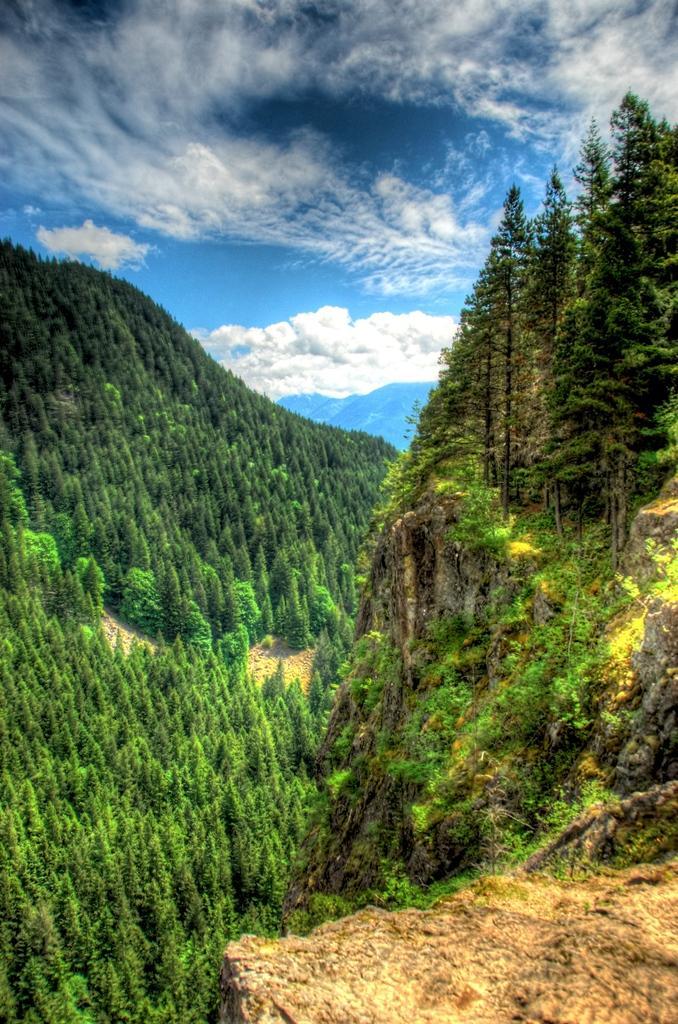In one or two sentences, can you explain what this image depicts? In this image I can see few green color trees and rock. The sky is in white and blue color. 